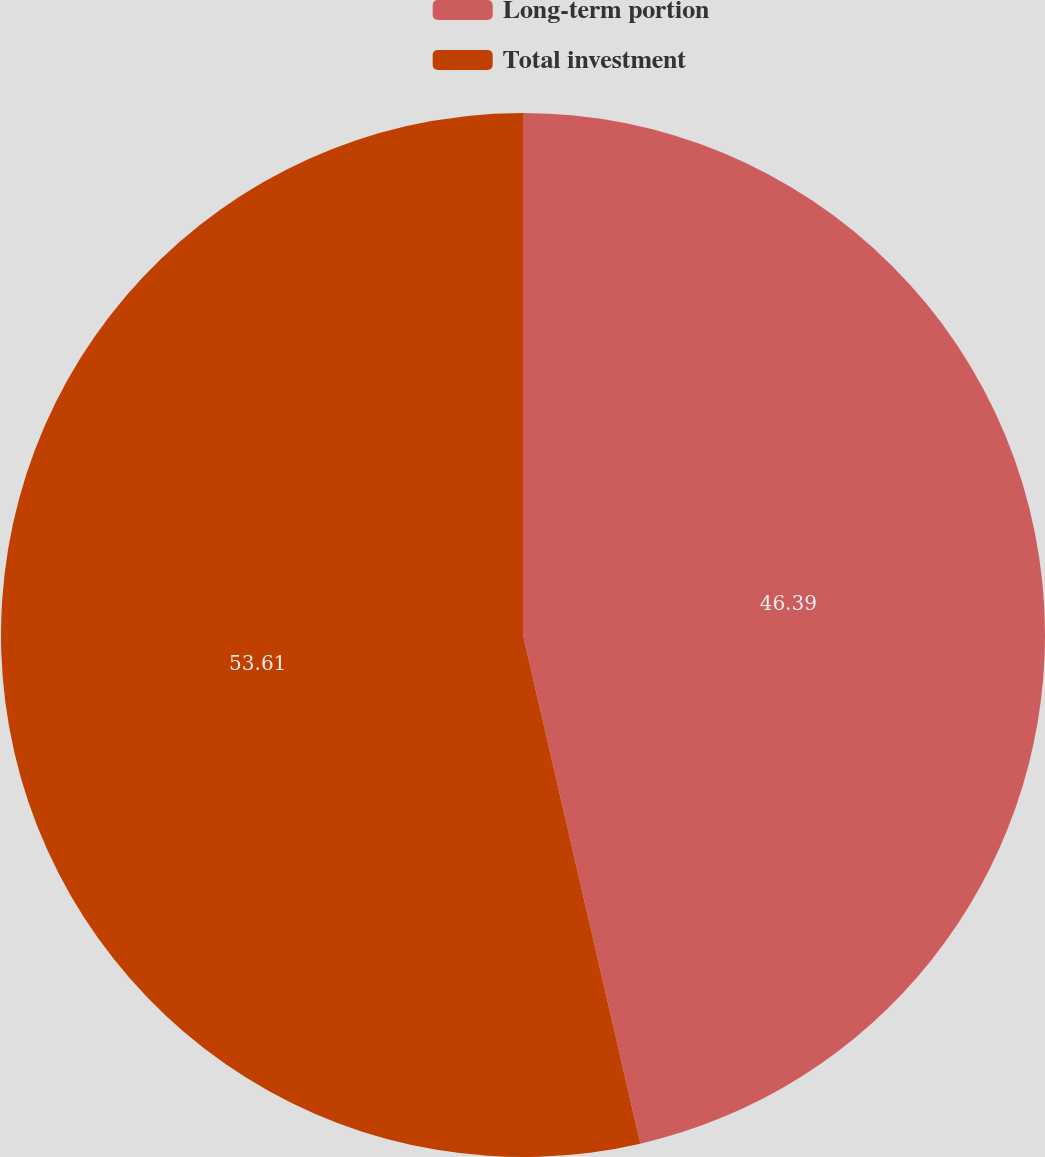Convert chart to OTSL. <chart><loc_0><loc_0><loc_500><loc_500><pie_chart><fcel>Long-term portion<fcel>Total investment<nl><fcel>46.39%<fcel>53.61%<nl></chart> 